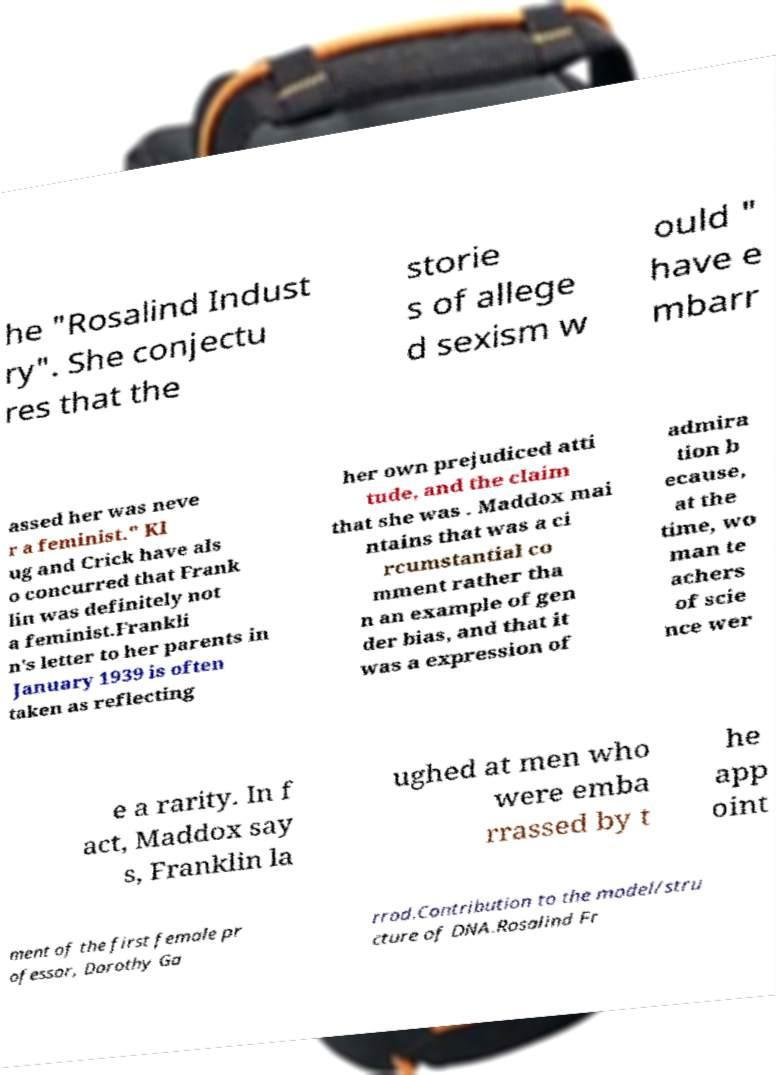For documentation purposes, I need the text within this image transcribed. Could you provide that? he "Rosalind Indust ry". She conjectu res that the storie s of allege d sexism w ould " have e mbarr assed her was neve r a feminist." Kl ug and Crick have als o concurred that Frank lin was definitely not a feminist.Frankli n's letter to her parents in January 1939 is often taken as reflecting her own prejudiced atti tude, and the claim that she was . Maddox mai ntains that was a ci rcumstantial co mment rather tha n an example of gen der bias, and that it was a expression of admira tion b ecause, at the time, wo man te achers of scie nce wer e a rarity. In f act, Maddox say s, Franklin la ughed at men who were emba rrassed by t he app oint ment of the first female pr ofessor, Dorothy Ga rrod.Contribution to the model/stru cture of DNA.Rosalind Fr 